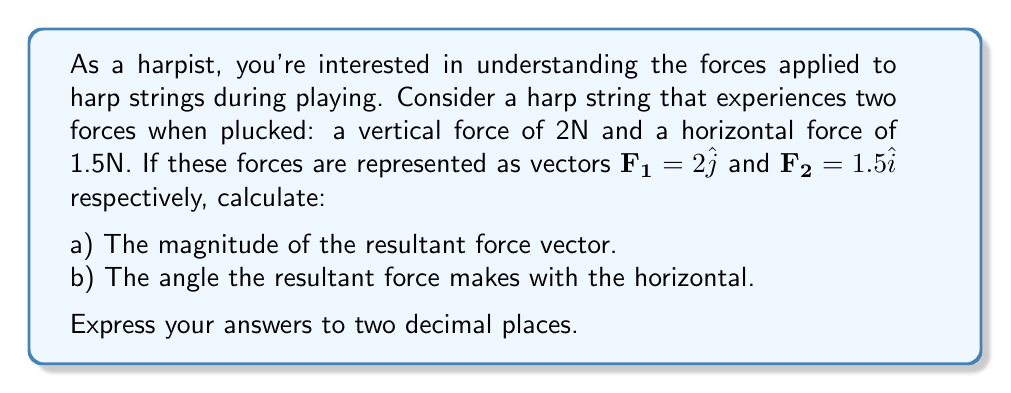Can you answer this question? Let's approach this step-by-step:

1) First, we need to find the resultant force vector. This is done by adding the two force vectors:

   $\mathbf{F_R} = \mathbf{F_1} + \mathbf{F_2} = 2\hat{j} + 1.5\hat{i}$

2) Now we have the resultant force vector: $\mathbf{F_R} = 1.5\hat{i} + 2\hat{j}$

3) To find the magnitude of this vector, we use the Pythagorean theorem:

   $|\mathbf{F_R}| = \sqrt{(1.5)^2 + 2^2}$

4) Calculating:
   
   $|\mathbf{F_R}| = \sqrt{2.25 + 4} = \sqrt{6.25} = 2.5$ N

5) To find the angle the resultant force makes with the horizontal, we use the arctangent function:

   $\theta = \tan^{-1}(\frac{y}{x}) = \tan^{-1}(\frac{2}{1.5})$

6) Calculating:
   
   $\theta = \tan^{-1}(1.3333...) \approx 53.13°$

Therefore, the magnitude of the resultant force is 2.50 N, and it makes an angle of approximately 53.13° with the horizontal.
Answer: a) 2.50 N
b) 53.13° 